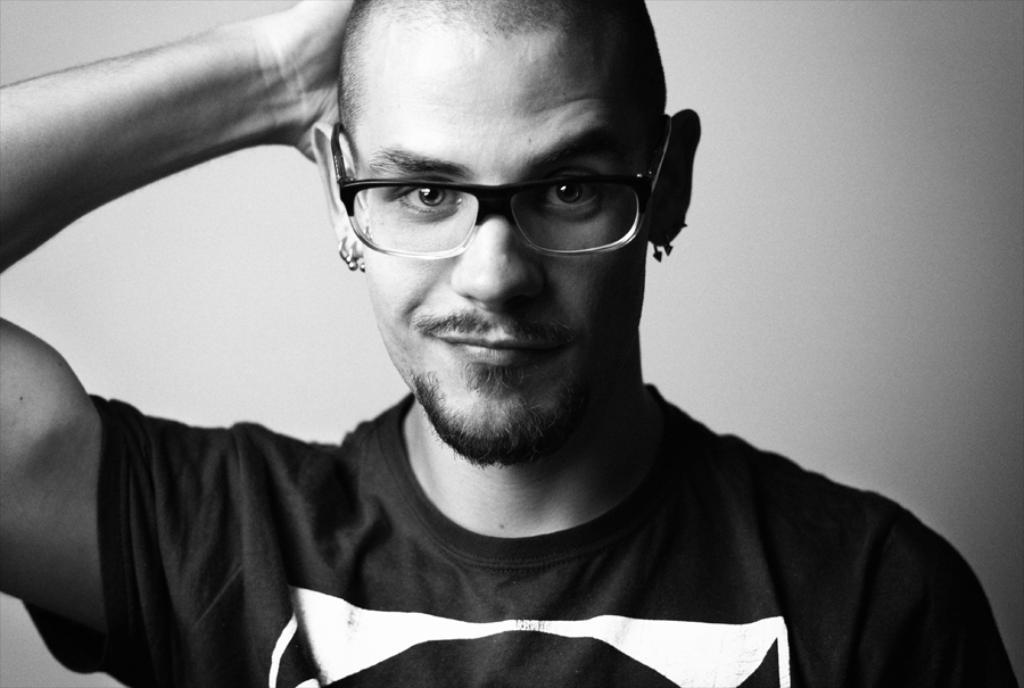Please provide a concise description of this image. In this picture there is a man with t-shirt and spectacles and he is wearing earrings. 